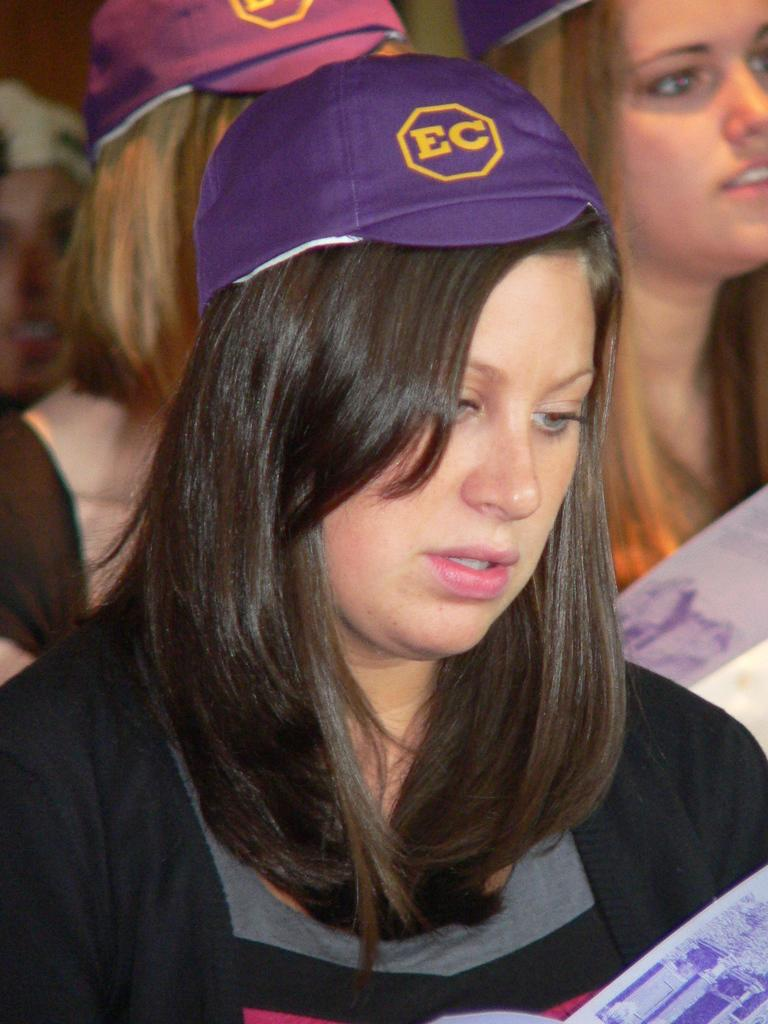<image>
Give a short and clear explanation of the subsequent image. A young woman in a crowd, wearing a purple EC hat. 